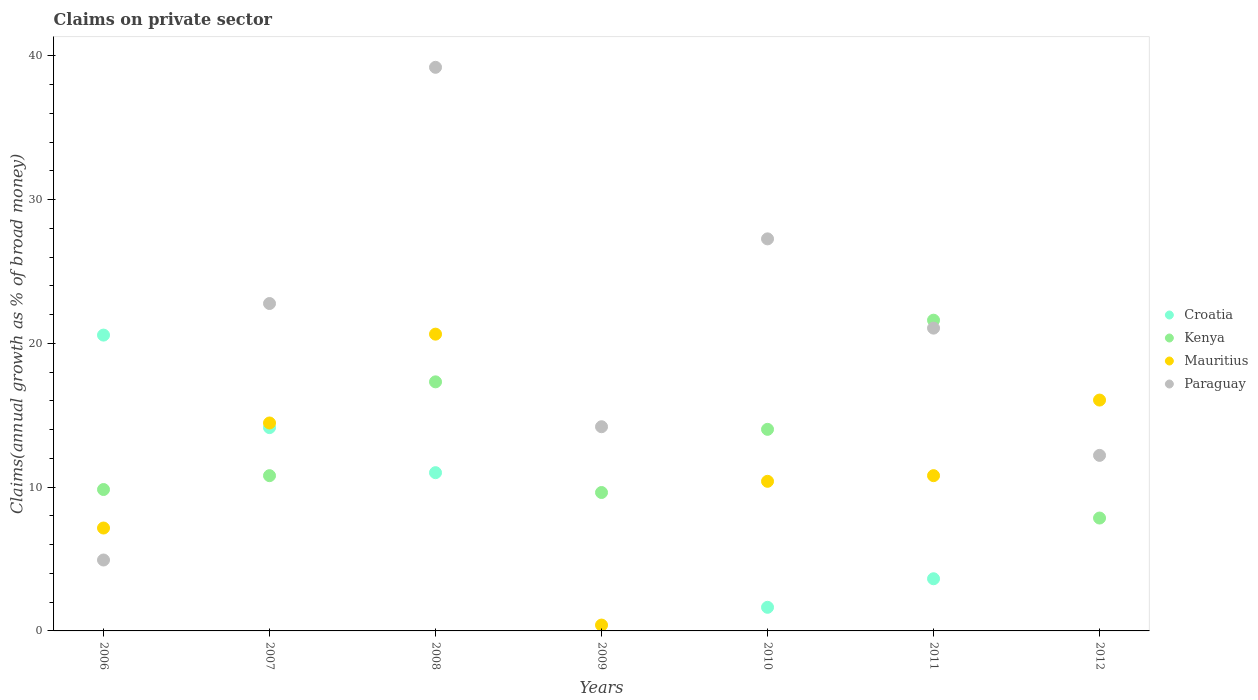How many different coloured dotlines are there?
Your response must be concise. 4. What is the percentage of broad money claimed on private sector in Croatia in 2012?
Give a very brief answer. 0. Across all years, what is the maximum percentage of broad money claimed on private sector in Kenya?
Your response must be concise. 21.62. In which year was the percentage of broad money claimed on private sector in Croatia maximum?
Your response must be concise. 2006. What is the total percentage of broad money claimed on private sector in Croatia in the graph?
Give a very brief answer. 51. What is the difference between the percentage of broad money claimed on private sector in Mauritius in 2010 and that in 2011?
Keep it short and to the point. -0.39. What is the difference between the percentage of broad money claimed on private sector in Croatia in 2011 and the percentage of broad money claimed on private sector in Paraguay in 2008?
Provide a short and direct response. -35.58. What is the average percentage of broad money claimed on private sector in Kenya per year?
Give a very brief answer. 13.01. In the year 2007, what is the difference between the percentage of broad money claimed on private sector in Kenya and percentage of broad money claimed on private sector in Paraguay?
Ensure brevity in your answer.  -11.98. In how many years, is the percentage of broad money claimed on private sector in Mauritius greater than 32 %?
Offer a very short reply. 0. What is the ratio of the percentage of broad money claimed on private sector in Paraguay in 2010 to that in 2011?
Your answer should be very brief. 1.29. Is the difference between the percentage of broad money claimed on private sector in Kenya in 2006 and 2008 greater than the difference between the percentage of broad money claimed on private sector in Paraguay in 2006 and 2008?
Your answer should be very brief. Yes. What is the difference between the highest and the second highest percentage of broad money claimed on private sector in Croatia?
Provide a succinct answer. 6.44. What is the difference between the highest and the lowest percentage of broad money claimed on private sector in Croatia?
Your answer should be compact. 20.58. In how many years, is the percentage of broad money claimed on private sector in Kenya greater than the average percentage of broad money claimed on private sector in Kenya taken over all years?
Keep it short and to the point. 3. Is the sum of the percentage of broad money claimed on private sector in Paraguay in 2006 and 2010 greater than the maximum percentage of broad money claimed on private sector in Kenya across all years?
Provide a succinct answer. Yes. Is the percentage of broad money claimed on private sector in Mauritius strictly greater than the percentage of broad money claimed on private sector in Paraguay over the years?
Give a very brief answer. No. How many dotlines are there?
Provide a short and direct response. 4. What is the difference between two consecutive major ticks on the Y-axis?
Your response must be concise. 10. Are the values on the major ticks of Y-axis written in scientific E-notation?
Your answer should be compact. No. Does the graph contain grids?
Ensure brevity in your answer.  No. How are the legend labels stacked?
Ensure brevity in your answer.  Vertical. What is the title of the graph?
Provide a short and direct response. Claims on private sector. Does "Bolivia" appear as one of the legend labels in the graph?
Ensure brevity in your answer.  No. What is the label or title of the Y-axis?
Offer a very short reply. Claims(annual growth as % of broad money). What is the Claims(annual growth as % of broad money) in Croatia in 2006?
Keep it short and to the point. 20.58. What is the Claims(annual growth as % of broad money) in Kenya in 2006?
Give a very brief answer. 9.84. What is the Claims(annual growth as % of broad money) of Mauritius in 2006?
Offer a very short reply. 7.16. What is the Claims(annual growth as % of broad money) of Paraguay in 2006?
Ensure brevity in your answer.  4.93. What is the Claims(annual growth as % of broad money) in Croatia in 2007?
Offer a terse response. 14.14. What is the Claims(annual growth as % of broad money) of Kenya in 2007?
Provide a succinct answer. 10.8. What is the Claims(annual growth as % of broad money) of Mauritius in 2007?
Give a very brief answer. 14.47. What is the Claims(annual growth as % of broad money) of Paraguay in 2007?
Offer a terse response. 22.78. What is the Claims(annual growth as % of broad money) of Croatia in 2008?
Your answer should be very brief. 11.01. What is the Claims(annual growth as % of broad money) in Kenya in 2008?
Offer a terse response. 17.33. What is the Claims(annual growth as % of broad money) of Mauritius in 2008?
Offer a terse response. 20.65. What is the Claims(annual growth as % of broad money) of Paraguay in 2008?
Give a very brief answer. 39.21. What is the Claims(annual growth as % of broad money) of Croatia in 2009?
Make the answer very short. 0. What is the Claims(annual growth as % of broad money) of Kenya in 2009?
Provide a succinct answer. 9.63. What is the Claims(annual growth as % of broad money) in Mauritius in 2009?
Provide a short and direct response. 0.41. What is the Claims(annual growth as % of broad money) in Paraguay in 2009?
Keep it short and to the point. 14.2. What is the Claims(annual growth as % of broad money) in Croatia in 2010?
Make the answer very short. 1.64. What is the Claims(annual growth as % of broad money) of Kenya in 2010?
Your response must be concise. 14.02. What is the Claims(annual growth as % of broad money) of Mauritius in 2010?
Offer a terse response. 10.41. What is the Claims(annual growth as % of broad money) in Paraguay in 2010?
Provide a short and direct response. 27.27. What is the Claims(annual growth as % of broad money) in Croatia in 2011?
Offer a very short reply. 3.63. What is the Claims(annual growth as % of broad money) of Kenya in 2011?
Make the answer very short. 21.62. What is the Claims(annual growth as % of broad money) of Mauritius in 2011?
Your answer should be very brief. 10.8. What is the Claims(annual growth as % of broad money) of Paraguay in 2011?
Offer a terse response. 21.06. What is the Claims(annual growth as % of broad money) of Kenya in 2012?
Provide a short and direct response. 7.85. What is the Claims(annual growth as % of broad money) in Mauritius in 2012?
Offer a very short reply. 16.06. What is the Claims(annual growth as % of broad money) of Paraguay in 2012?
Offer a terse response. 12.21. Across all years, what is the maximum Claims(annual growth as % of broad money) of Croatia?
Your response must be concise. 20.58. Across all years, what is the maximum Claims(annual growth as % of broad money) of Kenya?
Your response must be concise. 21.62. Across all years, what is the maximum Claims(annual growth as % of broad money) of Mauritius?
Offer a terse response. 20.65. Across all years, what is the maximum Claims(annual growth as % of broad money) in Paraguay?
Your answer should be very brief. 39.21. Across all years, what is the minimum Claims(annual growth as % of broad money) in Croatia?
Provide a short and direct response. 0. Across all years, what is the minimum Claims(annual growth as % of broad money) in Kenya?
Provide a short and direct response. 7.85. Across all years, what is the minimum Claims(annual growth as % of broad money) of Mauritius?
Your response must be concise. 0.41. Across all years, what is the minimum Claims(annual growth as % of broad money) of Paraguay?
Make the answer very short. 4.93. What is the total Claims(annual growth as % of broad money) in Croatia in the graph?
Provide a short and direct response. 51. What is the total Claims(annual growth as % of broad money) of Kenya in the graph?
Give a very brief answer. 91.09. What is the total Claims(annual growth as % of broad money) of Mauritius in the graph?
Offer a terse response. 79.95. What is the total Claims(annual growth as % of broad money) in Paraguay in the graph?
Keep it short and to the point. 141.67. What is the difference between the Claims(annual growth as % of broad money) in Croatia in 2006 and that in 2007?
Keep it short and to the point. 6.44. What is the difference between the Claims(annual growth as % of broad money) of Kenya in 2006 and that in 2007?
Provide a succinct answer. -0.96. What is the difference between the Claims(annual growth as % of broad money) in Mauritius in 2006 and that in 2007?
Offer a terse response. -7.31. What is the difference between the Claims(annual growth as % of broad money) of Paraguay in 2006 and that in 2007?
Offer a very short reply. -17.84. What is the difference between the Claims(annual growth as % of broad money) of Croatia in 2006 and that in 2008?
Provide a short and direct response. 9.57. What is the difference between the Claims(annual growth as % of broad money) of Kenya in 2006 and that in 2008?
Your response must be concise. -7.49. What is the difference between the Claims(annual growth as % of broad money) in Mauritius in 2006 and that in 2008?
Provide a short and direct response. -13.49. What is the difference between the Claims(annual growth as % of broad money) of Paraguay in 2006 and that in 2008?
Provide a succinct answer. -34.28. What is the difference between the Claims(annual growth as % of broad money) in Kenya in 2006 and that in 2009?
Your response must be concise. 0.21. What is the difference between the Claims(annual growth as % of broad money) of Mauritius in 2006 and that in 2009?
Give a very brief answer. 6.75. What is the difference between the Claims(annual growth as % of broad money) in Paraguay in 2006 and that in 2009?
Provide a succinct answer. -9.27. What is the difference between the Claims(annual growth as % of broad money) in Croatia in 2006 and that in 2010?
Your response must be concise. 18.94. What is the difference between the Claims(annual growth as % of broad money) in Kenya in 2006 and that in 2010?
Your response must be concise. -4.19. What is the difference between the Claims(annual growth as % of broad money) in Mauritius in 2006 and that in 2010?
Make the answer very short. -3.25. What is the difference between the Claims(annual growth as % of broad money) of Paraguay in 2006 and that in 2010?
Your answer should be very brief. -22.34. What is the difference between the Claims(annual growth as % of broad money) in Croatia in 2006 and that in 2011?
Provide a succinct answer. 16.95. What is the difference between the Claims(annual growth as % of broad money) of Kenya in 2006 and that in 2011?
Your answer should be compact. -11.78. What is the difference between the Claims(annual growth as % of broad money) in Mauritius in 2006 and that in 2011?
Offer a very short reply. -3.64. What is the difference between the Claims(annual growth as % of broad money) of Paraguay in 2006 and that in 2011?
Make the answer very short. -16.13. What is the difference between the Claims(annual growth as % of broad money) in Kenya in 2006 and that in 2012?
Make the answer very short. 1.98. What is the difference between the Claims(annual growth as % of broad money) in Mauritius in 2006 and that in 2012?
Your answer should be very brief. -8.9. What is the difference between the Claims(annual growth as % of broad money) in Paraguay in 2006 and that in 2012?
Provide a succinct answer. -7.28. What is the difference between the Claims(annual growth as % of broad money) of Croatia in 2007 and that in 2008?
Offer a terse response. 3.14. What is the difference between the Claims(annual growth as % of broad money) in Kenya in 2007 and that in 2008?
Offer a very short reply. -6.53. What is the difference between the Claims(annual growth as % of broad money) in Mauritius in 2007 and that in 2008?
Offer a terse response. -6.18. What is the difference between the Claims(annual growth as % of broad money) in Paraguay in 2007 and that in 2008?
Offer a very short reply. -16.43. What is the difference between the Claims(annual growth as % of broad money) in Kenya in 2007 and that in 2009?
Ensure brevity in your answer.  1.17. What is the difference between the Claims(annual growth as % of broad money) of Mauritius in 2007 and that in 2009?
Provide a succinct answer. 14.06. What is the difference between the Claims(annual growth as % of broad money) of Paraguay in 2007 and that in 2009?
Provide a short and direct response. 8.57. What is the difference between the Claims(annual growth as % of broad money) in Croatia in 2007 and that in 2010?
Offer a terse response. 12.5. What is the difference between the Claims(annual growth as % of broad money) of Kenya in 2007 and that in 2010?
Give a very brief answer. -3.22. What is the difference between the Claims(annual growth as % of broad money) of Mauritius in 2007 and that in 2010?
Offer a very short reply. 4.06. What is the difference between the Claims(annual growth as % of broad money) of Paraguay in 2007 and that in 2010?
Provide a succinct answer. -4.5. What is the difference between the Claims(annual growth as % of broad money) in Croatia in 2007 and that in 2011?
Offer a terse response. 10.52. What is the difference between the Claims(annual growth as % of broad money) in Kenya in 2007 and that in 2011?
Provide a short and direct response. -10.82. What is the difference between the Claims(annual growth as % of broad money) of Mauritius in 2007 and that in 2011?
Provide a short and direct response. 3.67. What is the difference between the Claims(annual growth as % of broad money) in Paraguay in 2007 and that in 2011?
Ensure brevity in your answer.  1.71. What is the difference between the Claims(annual growth as % of broad money) in Kenya in 2007 and that in 2012?
Your answer should be compact. 2.95. What is the difference between the Claims(annual growth as % of broad money) in Mauritius in 2007 and that in 2012?
Your response must be concise. -1.59. What is the difference between the Claims(annual growth as % of broad money) of Paraguay in 2007 and that in 2012?
Offer a very short reply. 10.56. What is the difference between the Claims(annual growth as % of broad money) of Kenya in 2008 and that in 2009?
Provide a succinct answer. 7.7. What is the difference between the Claims(annual growth as % of broad money) in Mauritius in 2008 and that in 2009?
Provide a succinct answer. 20.24. What is the difference between the Claims(annual growth as % of broad money) of Paraguay in 2008 and that in 2009?
Your answer should be very brief. 25. What is the difference between the Claims(annual growth as % of broad money) in Croatia in 2008 and that in 2010?
Keep it short and to the point. 9.37. What is the difference between the Claims(annual growth as % of broad money) in Kenya in 2008 and that in 2010?
Your answer should be compact. 3.3. What is the difference between the Claims(annual growth as % of broad money) in Mauritius in 2008 and that in 2010?
Provide a short and direct response. 10.24. What is the difference between the Claims(annual growth as % of broad money) in Paraguay in 2008 and that in 2010?
Make the answer very short. 11.93. What is the difference between the Claims(annual growth as % of broad money) in Croatia in 2008 and that in 2011?
Your response must be concise. 7.38. What is the difference between the Claims(annual growth as % of broad money) of Kenya in 2008 and that in 2011?
Ensure brevity in your answer.  -4.29. What is the difference between the Claims(annual growth as % of broad money) in Mauritius in 2008 and that in 2011?
Make the answer very short. 9.84. What is the difference between the Claims(annual growth as % of broad money) in Paraguay in 2008 and that in 2011?
Offer a terse response. 18.14. What is the difference between the Claims(annual growth as % of broad money) of Kenya in 2008 and that in 2012?
Ensure brevity in your answer.  9.47. What is the difference between the Claims(annual growth as % of broad money) in Mauritius in 2008 and that in 2012?
Provide a short and direct response. 4.59. What is the difference between the Claims(annual growth as % of broad money) in Paraguay in 2008 and that in 2012?
Provide a short and direct response. 27. What is the difference between the Claims(annual growth as % of broad money) of Kenya in 2009 and that in 2010?
Offer a terse response. -4.39. What is the difference between the Claims(annual growth as % of broad money) in Mauritius in 2009 and that in 2010?
Offer a very short reply. -10. What is the difference between the Claims(annual growth as % of broad money) in Paraguay in 2009 and that in 2010?
Provide a short and direct response. -13.07. What is the difference between the Claims(annual growth as % of broad money) in Kenya in 2009 and that in 2011?
Offer a very short reply. -11.99. What is the difference between the Claims(annual growth as % of broad money) of Mauritius in 2009 and that in 2011?
Make the answer very short. -10.39. What is the difference between the Claims(annual growth as % of broad money) in Paraguay in 2009 and that in 2011?
Offer a terse response. -6.86. What is the difference between the Claims(annual growth as % of broad money) in Kenya in 2009 and that in 2012?
Your answer should be compact. 1.78. What is the difference between the Claims(annual growth as % of broad money) of Mauritius in 2009 and that in 2012?
Offer a very short reply. -15.65. What is the difference between the Claims(annual growth as % of broad money) of Paraguay in 2009 and that in 2012?
Your response must be concise. 1.99. What is the difference between the Claims(annual growth as % of broad money) of Croatia in 2010 and that in 2011?
Give a very brief answer. -1.99. What is the difference between the Claims(annual growth as % of broad money) of Kenya in 2010 and that in 2011?
Your response must be concise. -7.59. What is the difference between the Claims(annual growth as % of broad money) of Mauritius in 2010 and that in 2011?
Offer a very short reply. -0.39. What is the difference between the Claims(annual growth as % of broad money) of Paraguay in 2010 and that in 2011?
Provide a succinct answer. 6.21. What is the difference between the Claims(annual growth as % of broad money) in Kenya in 2010 and that in 2012?
Your answer should be very brief. 6.17. What is the difference between the Claims(annual growth as % of broad money) of Mauritius in 2010 and that in 2012?
Offer a terse response. -5.65. What is the difference between the Claims(annual growth as % of broad money) of Paraguay in 2010 and that in 2012?
Provide a short and direct response. 15.06. What is the difference between the Claims(annual growth as % of broad money) of Kenya in 2011 and that in 2012?
Your answer should be compact. 13.76. What is the difference between the Claims(annual growth as % of broad money) in Mauritius in 2011 and that in 2012?
Your response must be concise. -5.26. What is the difference between the Claims(annual growth as % of broad money) of Paraguay in 2011 and that in 2012?
Your answer should be compact. 8.85. What is the difference between the Claims(annual growth as % of broad money) of Croatia in 2006 and the Claims(annual growth as % of broad money) of Kenya in 2007?
Provide a succinct answer. 9.78. What is the difference between the Claims(annual growth as % of broad money) in Croatia in 2006 and the Claims(annual growth as % of broad money) in Mauritius in 2007?
Your answer should be compact. 6.11. What is the difference between the Claims(annual growth as % of broad money) of Croatia in 2006 and the Claims(annual growth as % of broad money) of Paraguay in 2007?
Make the answer very short. -2.2. What is the difference between the Claims(annual growth as % of broad money) of Kenya in 2006 and the Claims(annual growth as % of broad money) of Mauritius in 2007?
Make the answer very short. -4.63. What is the difference between the Claims(annual growth as % of broad money) of Kenya in 2006 and the Claims(annual growth as % of broad money) of Paraguay in 2007?
Provide a short and direct response. -12.94. What is the difference between the Claims(annual growth as % of broad money) of Mauritius in 2006 and the Claims(annual growth as % of broad money) of Paraguay in 2007?
Give a very brief answer. -15.62. What is the difference between the Claims(annual growth as % of broad money) of Croatia in 2006 and the Claims(annual growth as % of broad money) of Kenya in 2008?
Ensure brevity in your answer.  3.25. What is the difference between the Claims(annual growth as % of broad money) in Croatia in 2006 and the Claims(annual growth as % of broad money) in Mauritius in 2008?
Give a very brief answer. -0.07. What is the difference between the Claims(annual growth as % of broad money) in Croatia in 2006 and the Claims(annual growth as % of broad money) in Paraguay in 2008?
Your answer should be very brief. -18.63. What is the difference between the Claims(annual growth as % of broad money) of Kenya in 2006 and the Claims(annual growth as % of broad money) of Mauritius in 2008?
Your answer should be very brief. -10.81. What is the difference between the Claims(annual growth as % of broad money) of Kenya in 2006 and the Claims(annual growth as % of broad money) of Paraguay in 2008?
Offer a very short reply. -29.37. What is the difference between the Claims(annual growth as % of broad money) of Mauritius in 2006 and the Claims(annual growth as % of broad money) of Paraguay in 2008?
Your answer should be very brief. -32.05. What is the difference between the Claims(annual growth as % of broad money) of Croatia in 2006 and the Claims(annual growth as % of broad money) of Kenya in 2009?
Ensure brevity in your answer.  10.95. What is the difference between the Claims(annual growth as % of broad money) of Croatia in 2006 and the Claims(annual growth as % of broad money) of Mauritius in 2009?
Provide a short and direct response. 20.17. What is the difference between the Claims(annual growth as % of broad money) in Croatia in 2006 and the Claims(annual growth as % of broad money) in Paraguay in 2009?
Ensure brevity in your answer.  6.37. What is the difference between the Claims(annual growth as % of broad money) of Kenya in 2006 and the Claims(annual growth as % of broad money) of Mauritius in 2009?
Make the answer very short. 9.43. What is the difference between the Claims(annual growth as % of broad money) in Kenya in 2006 and the Claims(annual growth as % of broad money) in Paraguay in 2009?
Make the answer very short. -4.37. What is the difference between the Claims(annual growth as % of broad money) in Mauritius in 2006 and the Claims(annual growth as % of broad money) in Paraguay in 2009?
Your answer should be compact. -7.05. What is the difference between the Claims(annual growth as % of broad money) in Croatia in 2006 and the Claims(annual growth as % of broad money) in Kenya in 2010?
Offer a very short reply. 6.56. What is the difference between the Claims(annual growth as % of broad money) of Croatia in 2006 and the Claims(annual growth as % of broad money) of Mauritius in 2010?
Your answer should be compact. 10.17. What is the difference between the Claims(annual growth as % of broad money) in Croatia in 2006 and the Claims(annual growth as % of broad money) in Paraguay in 2010?
Keep it short and to the point. -6.69. What is the difference between the Claims(annual growth as % of broad money) of Kenya in 2006 and the Claims(annual growth as % of broad money) of Mauritius in 2010?
Provide a short and direct response. -0.57. What is the difference between the Claims(annual growth as % of broad money) in Kenya in 2006 and the Claims(annual growth as % of broad money) in Paraguay in 2010?
Your answer should be very brief. -17.44. What is the difference between the Claims(annual growth as % of broad money) in Mauritius in 2006 and the Claims(annual growth as % of broad money) in Paraguay in 2010?
Your answer should be very brief. -20.12. What is the difference between the Claims(annual growth as % of broad money) in Croatia in 2006 and the Claims(annual growth as % of broad money) in Kenya in 2011?
Your response must be concise. -1.04. What is the difference between the Claims(annual growth as % of broad money) of Croatia in 2006 and the Claims(annual growth as % of broad money) of Mauritius in 2011?
Make the answer very short. 9.78. What is the difference between the Claims(annual growth as % of broad money) in Croatia in 2006 and the Claims(annual growth as % of broad money) in Paraguay in 2011?
Your answer should be very brief. -0.48. What is the difference between the Claims(annual growth as % of broad money) in Kenya in 2006 and the Claims(annual growth as % of broad money) in Mauritius in 2011?
Your answer should be compact. -0.96. What is the difference between the Claims(annual growth as % of broad money) of Kenya in 2006 and the Claims(annual growth as % of broad money) of Paraguay in 2011?
Offer a very short reply. -11.23. What is the difference between the Claims(annual growth as % of broad money) of Mauritius in 2006 and the Claims(annual growth as % of broad money) of Paraguay in 2011?
Make the answer very short. -13.91. What is the difference between the Claims(annual growth as % of broad money) of Croatia in 2006 and the Claims(annual growth as % of broad money) of Kenya in 2012?
Provide a short and direct response. 12.73. What is the difference between the Claims(annual growth as % of broad money) in Croatia in 2006 and the Claims(annual growth as % of broad money) in Mauritius in 2012?
Offer a very short reply. 4.52. What is the difference between the Claims(annual growth as % of broad money) in Croatia in 2006 and the Claims(annual growth as % of broad money) in Paraguay in 2012?
Ensure brevity in your answer.  8.37. What is the difference between the Claims(annual growth as % of broad money) in Kenya in 2006 and the Claims(annual growth as % of broad money) in Mauritius in 2012?
Offer a very short reply. -6.22. What is the difference between the Claims(annual growth as % of broad money) of Kenya in 2006 and the Claims(annual growth as % of broad money) of Paraguay in 2012?
Your answer should be very brief. -2.38. What is the difference between the Claims(annual growth as % of broad money) in Mauritius in 2006 and the Claims(annual growth as % of broad money) in Paraguay in 2012?
Offer a very short reply. -5.05. What is the difference between the Claims(annual growth as % of broad money) of Croatia in 2007 and the Claims(annual growth as % of broad money) of Kenya in 2008?
Provide a short and direct response. -3.18. What is the difference between the Claims(annual growth as % of broad money) in Croatia in 2007 and the Claims(annual growth as % of broad money) in Mauritius in 2008?
Give a very brief answer. -6.5. What is the difference between the Claims(annual growth as % of broad money) in Croatia in 2007 and the Claims(annual growth as % of broad money) in Paraguay in 2008?
Your answer should be very brief. -25.06. What is the difference between the Claims(annual growth as % of broad money) of Kenya in 2007 and the Claims(annual growth as % of broad money) of Mauritius in 2008?
Ensure brevity in your answer.  -9.85. What is the difference between the Claims(annual growth as % of broad money) in Kenya in 2007 and the Claims(annual growth as % of broad money) in Paraguay in 2008?
Give a very brief answer. -28.41. What is the difference between the Claims(annual growth as % of broad money) of Mauritius in 2007 and the Claims(annual growth as % of broad money) of Paraguay in 2008?
Offer a terse response. -24.74. What is the difference between the Claims(annual growth as % of broad money) of Croatia in 2007 and the Claims(annual growth as % of broad money) of Kenya in 2009?
Offer a terse response. 4.52. What is the difference between the Claims(annual growth as % of broad money) of Croatia in 2007 and the Claims(annual growth as % of broad money) of Mauritius in 2009?
Provide a succinct answer. 13.74. What is the difference between the Claims(annual growth as % of broad money) of Croatia in 2007 and the Claims(annual growth as % of broad money) of Paraguay in 2009?
Ensure brevity in your answer.  -0.06. What is the difference between the Claims(annual growth as % of broad money) of Kenya in 2007 and the Claims(annual growth as % of broad money) of Mauritius in 2009?
Keep it short and to the point. 10.39. What is the difference between the Claims(annual growth as % of broad money) of Kenya in 2007 and the Claims(annual growth as % of broad money) of Paraguay in 2009?
Provide a succinct answer. -3.4. What is the difference between the Claims(annual growth as % of broad money) of Mauritius in 2007 and the Claims(annual growth as % of broad money) of Paraguay in 2009?
Your answer should be very brief. 0.26. What is the difference between the Claims(annual growth as % of broad money) in Croatia in 2007 and the Claims(annual growth as % of broad money) in Kenya in 2010?
Your answer should be compact. 0.12. What is the difference between the Claims(annual growth as % of broad money) of Croatia in 2007 and the Claims(annual growth as % of broad money) of Mauritius in 2010?
Ensure brevity in your answer.  3.74. What is the difference between the Claims(annual growth as % of broad money) of Croatia in 2007 and the Claims(annual growth as % of broad money) of Paraguay in 2010?
Ensure brevity in your answer.  -13.13. What is the difference between the Claims(annual growth as % of broad money) in Kenya in 2007 and the Claims(annual growth as % of broad money) in Mauritius in 2010?
Offer a terse response. 0.39. What is the difference between the Claims(annual growth as % of broad money) of Kenya in 2007 and the Claims(annual growth as % of broad money) of Paraguay in 2010?
Make the answer very short. -16.47. What is the difference between the Claims(annual growth as % of broad money) of Mauritius in 2007 and the Claims(annual growth as % of broad money) of Paraguay in 2010?
Make the answer very short. -12.81. What is the difference between the Claims(annual growth as % of broad money) of Croatia in 2007 and the Claims(annual growth as % of broad money) of Kenya in 2011?
Your response must be concise. -7.47. What is the difference between the Claims(annual growth as % of broad money) of Croatia in 2007 and the Claims(annual growth as % of broad money) of Mauritius in 2011?
Provide a succinct answer. 3.34. What is the difference between the Claims(annual growth as % of broad money) in Croatia in 2007 and the Claims(annual growth as % of broad money) in Paraguay in 2011?
Offer a very short reply. -6.92. What is the difference between the Claims(annual growth as % of broad money) in Kenya in 2007 and the Claims(annual growth as % of broad money) in Mauritius in 2011?
Provide a succinct answer. -0. What is the difference between the Claims(annual growth as % of broad money) in Kenya in 2007 and the Claims(annual growth as % of broad money) in Paraguay in 2011?
Offer a terse response. -10.26. What is the difference between the Claims(annual growth as % of broad money) of Mauritius in 2007 and the Claims(annual growth as % of broad money) of Paraguay in 2011?
Make the answer very short. -6.6. What is the difference between the Claims(annual growth as % of broad money) of Croatia in 2007 and the Claims(annual growth as % of broad money) of Kenya in 2012?
Keep it short and to the point. 6.29. What is the difference between the Claims(annual growth as % of broad money) of Croatia in 2007 and the Claims(annual growth as % of broad money) of Mauritius in 2012?
Make the answer very short. -1.92. What is the difference between the Claims(annual growth as % of broad money) in Croatia in 2007 and the Claims(annual growth as % of broad money) in Paraguay in 2012?
Give a very brief answer. 1.93. What is the difference between the Claims(annual growth as % of broad money) in Kenya in 2007 and the Claims(annual growth as % of broad money) in Mauritius in 2012?
Ensure brevity in your answer.  -5.26. What is the difference between the Claims(annual growth as % of broad money) of Kenya in 2007 and the Claims(annual growth as % of broad money) of Paraguay in 2012?
Give a very brief answer. -1.41. What is the difference between the Claims(annual growth as % of broad money) in Mauritius in 2007 and the Claims(annual growth as % of broad money) in Paraguay in 2012?
Provide a succinct answer. 2.25. What is the difference between the Claims(annual growth as % of broad money) in Croatia in 2008 and the Claims(annual growth as % of broad money) in Kenya in 2009?
Your answer should be very brief. 1.38. What is the difference between the Claims(annual growth as % of broad money) of Croatia in 2008 and the Claims(annual growth as % of broad money) of Mauritius in 2009?
Your answer should be very brief. 10.6. What is the difference between the Claims(annual growth as % of broad money) in Croatia in 2008 and the Claims(annual growth as % of broad money) in Paraguay in 2009?
Provide a succinct answer. -3.2. What is the difference between the Claims(annual growth as % of broad money) in Kenya in 2008 and the Claims(annual growth as % of broad money) in Mauritius in 2009?
Provide a short and direct response. 16.92. What is the difference between the Claims(annual growth as % of broad money) in Kenya in 2008 and the Claims(annual growth as % of broad money) in Paraguay in 2009?
Your answer should be compact. 3.12. What is the difference between the Claims(annual growth as % of broad money) of Mauritius in 2008 and the Claims(annual growth as % of broad money) of Paraguay in 2009?
Offer a very short reply. 6.44. What is the difference between the Claims(annual growth as % of broad money) in Croatia in 2008 and the Claims(annual growth as % of broad money) in Kenya in 2010?
Make the answer very short. -3.01. What is the difference between the Claims(annual growth as % of broad money) of Croatia in 2008 and the Claims(annual growth as % of broad money) of Mauritius in 2010?
Make the answer very short. 0.6. What is the difference between the Claims(annual growth as % of broad money) in Croatia in 2008 and the Claims(annual growth as % of broad money) in Paraguay in 2010?
Give a very brief answer. -16.27. What is the difference between the Claims(annual growth as % of broad money) of Kenya in 2008 and the Claims(annual growth as % of broad money) of Mauritius in 2010?
Ensure brevity in your answer.  6.92. What is the difference between the Claims(annual growth as % of broad money) in Kenya in 2008 and the Claims(annual growth as % of broad money) in Paraguay in 2010?
Give a very brief answer. -9.95. What is the difference between the Claims(annual growth as % of broad money) in Mauritius in 2008 and the Claims(annual growth as % of broad money) in Paraguay in 2010?
Your response must be concise. -6.63. What is the difference between the Claims(annual growth as % of broad money) of Croatia in 2008 and the Claims(annual growth as % of broad money) of Kenya in 2011?
Provide a succinct answer. -10.61. What is the difference between the Claims(annual growth as % of broad money) in Croatia in 2008 and the Claims(annual growth as % of broad money) in Mauritius in 2011?
Give a very brief answer. 0.21. What is the difference between the Claims(annual growth as % of broad money) in Croatia in 2008 and the Claims(annual growth as % of broad money) in Paraguay in 2011?
Offer a very short reply. -10.06. What is the difference between the Claims(annual growth as % of broad money) of Kenya in 2008 and the Claims(annual growth as % of broad money) of Mauritius in 2011?
Your answer should be compact. 6.53. What is the difference between the Claims(annual growth as % of broad money) of Kenya in 2008 and the Claims(annual growth as % of broad money) of Paraguay in 2011?
Ensure brevity in your answer.  -3.74. What is the difference between the Claims(annual growth as % of broad money) of Mauritius in 2008 and the Claims(annual growth as % of broad money) of Paraguay in 2011?
Your answer should be very brief. -0.42. What is the difference between the Claims(annual growth as % of broad money) in Croatia in 2008 and the Claims(annual growth as % of broad money) in Kenya in 2012?
Offer a terse response. 3.16. What is the difference between the Claims(annual growth as % of broad money) of Croatia in 2008 and the Claims(annual growth as % of broad money) of Mauritius in 2012?
Keep it short and to the point. -5.05. What is the difference between the Claims(annual growth as % of broad money) in Croatia in 2008 and the Claims(annual growth as % of broad money) in Paraguay in 2012?
Provide a succinct answer. -1.2. What is the difference between the Claims(annual growth as % of broad money) in Kenya in 2008 and the Claims(annual growth as % of broad money) in Mauritius in 2012?
Offer a very short reply. 1.27. What is the difference between the Claims(annual growth as % of broad money) of Kenya in 2008 and the Claims(annual growth as % of broad money) of Paraguay in 2012?
Give a very brief answer. 5.11. What is the difference between the Claims(annual growth as % of broad money) of Mauritius in 2008 and the Claims(annual growth as % of broad money) of Paraguay in 2012?
Your response must be concise. 8.43. What is the difference between the Claims(annual growth as % of broad money) in Kenya in 2009 and the Claims(annual growth as % of broad money) in Mauritius in 2010?
Provide a short and direct response. -0.78. What is the difference between the Claims(annual growth as % of broad money) in Kenya in 2009 and the Claims(annual growth as % of broad money) in Paraguay in 2010?
Ensure brevity in your answer.  -17.64. What is the difference between the Claims(annual growth as % of broad money) in Mauritius in 2009 and the Claims(annual growth as % of broad money) in Paraguay in 2010?
Ensure brevity in your answer.  -26.87. What is the difference between the Claims(annual growth as % of broad money) of Kenya in 2009 and the Claims(annual growth as % of broad money) of Mauritius in 2011?
Your answer should be very brief. -1.17. What is the difference between the Claims(annual growth as % of broad money) in Kenya in 2009 and the Claims(annual growth as % of broad money) in Paraguay in 2011?
Your response must be concise. -11.44. What is the difference between the Claims(annual growth as % of broad money) of Mauritius in 2009 and the Claims(annual growth as % of broad money) of Paraguay in 2011?
Provide a short and direct response. -20.66. What is the difference between the Claims(annual growth as % of broad money) of Kenya in 2009 and the Claims(annual growth as % of broad money) of Mauritius in 2012?
Ensure brevity in your answer.  -6.43. What is the difference between the Claims(annual growth as % of broad money) of Kenya in 2009 and the Claims(annual growth as % of broad money) of Paraguay in 2012?
Offer a very short reply. -2.58. What is the difference between the Claims(annual growth as % of broad money) of Mauritius in 2009 and the Claims(annual growth as % of broad money) of Paraguay in 2012?
Provide a short and direct response. -11.81. What is the difference between the Claims(annual growth as % of broad money) of Croatia in 2010 and the Claims(annual growth as % of broad money) of Kenya in 2011?
Provide a short and direct response. -19.97. What is the difference between the Claims(annual growth as % of broad money) of Croatia in 2010 and the Claims(annual growth as % of broad money) of Mauritius in 2011?
Your response must be concise. -9.16. What is the difference between the Claims(annual growth as % of broad money) of Croatia in 2010 and the Claims(annual growth as % of broad money) of Paraguay in 2011?
Your answer should be compact. -19.42. What is the difference between the Claims(annual growth as % of broad money) in Kenya in 2010 and the Claims(annual growth as % of broad money) in Mauritius in 2011?
Give a very brief answer. 3.22. What is the difference between the Claims(annual growth as % of broad money) in Kenya in 2010 and the Claims(annual growth as % of broad money) in Paraguay in 2011?
Provide a succinct answer. -7.04. What is the difference between the Claims(annual growth as % of broad money) in Mauritius in 2010 and the Claims(annual growth as % of broad money) in Paraguay in 2011?
Ensure brevity in your answer.  -10.66. What is the difference between the Claims(annual growth as % of broad money) in Croatia in 2010 and the Claims(annual growth as % of broad money) in Kenya in 2012?
Make the answer very short. -6.21. What is the difference between the Claims(annual growth as % of broad money) of Croatia in 2010 and the Claims(annual growth as % of broad money) of Mauritius in 2012?
Your answer should be compact. -14.42. What is the difference between the Claims(annual growth as % of broad money) in Croatia in 2010 and the Claims(annual growth as % of broad money) in Paraguay in 2012?
Offer a very short reply. -10.57. What is the difference between the Claims(annual growth as % of broad money) of Kenya in 2010 and the Claims(annual growth as % of broad money) of Mauritius in 2012?
Offer a terse response. -2.04. What is the difference between the Claims(annual growth as % of broad money) of Kenya in 2010 and the Claims(annual growth as % of broad money) of Paraguay in 2012?
Offer a terse response. 1.81. What is the difference between the Claims(annual growth as % of broad money) of Mauritius in 2010 and the Claims(annual growth as % of broad money) of Paraguay in 2012?
Your response must be concise. -1.8. What is the difference between the Claims(annual growth as % of broad money) of Croatia in 2011 and the Claims(annual growth as % of broad money) of Kenya in 2012?
Provide a short and direct response. -4.22. What is the difference between the Claims(annual growth as % of broad money) of Croatia in 2011 and the Claims(annual growth as % of broad money) of Mauritius in 2012?
Provide a short and direct response. -12.43. What is the difference between the Claims(annual growth as % of broad money) of Croatia in 2011 and the Claims(annual growth as % of broad money) of Paraguay in 2012?
Offer a terse response. -8.58. What is the difference between the Claims(annual growth as % of broad money) of Kenya in 2011 and the Claims(annual growth as % of broad money) of Mauritius in 2012?
Make the answer very short. 5.56. What is the difference between the Claims(annual growth as % of broad money) of Kenya in 2011 and the Claims(annual growth as % of broad money) of Paraguay in 2012?
Give a very brief answer. 9.4. What is the difference between the Claims(annual growth as % of broad money) in Mauritius in 2011 and the Claims(annual growth as % of broad money) in Paraguay in 2012?
Your answer should be compact. -1.41. What is the average Claims(annual growth as % of broad money) of Croatia per year?
Offer a very short reply. 7.29. What is the average Claims(annual growth as % of broad money) of Kenya per year?
Make the answer very short. 13.01. What is the average Claims(annual growth as % of broad money) in Mauritius per year?
Your response must be concise. 11.42. What is the average Claims(annual growth as % of broad money) of Paraguay per year?
Offer a very short reply. 20.24. In the year 2006, what is the difference between the Claims(annual growth as % of broad money) of Croatia and Claims(annual growth as % of broad money) of Kenya?
Ensure brevity in your answer.  10.74. In the year 2006, what is the difference between the Claims(annual growth as % of broad money) of Croatia and Claims(annual growth as % of broad money) of Mauritius?
Your answer should be compact. 13.42. In the year 2006, what is the difference between the Claims(annual growth as % of broad money) in Croatia and Claims(annual growth as % of broad money) in Paraguay?
Offer a very short reply. 15.65. In the year 2006, what is the difference between the Claims(annual growth as % of broad money) in Kenya and Claims(annual growth as % of broad money) in Mauritius?
Offer a very short reply. 2.68. In the year 2006, what is the difference between the Claims(annual growth as % of broad money) of Kenya and Claims(annual growth as % of broad money) of Paraguay?
Your response must be concise. 4.9. In the year 2006, what is the difference between the Claims(annual growth as % of broad money) in Mauritius and Claims(annual growth as % of broad money) in Paraguay?
Offer a terse response. 2.23. In the year 2007, what is the difference between the Claims(annual growth as % of broad money) in Croatia and Claims(annual growth as % of broad money) in Kenya?
Your response must be concise. 3.34. In the year 2007, what is the difference between the Claims(annual growth as % of broad money) of Croatia and Claims(annual growth as % of broad money) of Mauritius?
Make the answer very short. -0.32. In the year 2007, what is the difference between the Claims(annual growth as % of broad money) in Croatia and Claims(annual growth as % of broad money) in Paraguay?
Keep it short and to the point. -8.63. In the year 2007, what is the difference between the Claims(annual growth as % of broad money) in Kenya and Claims(annual growth as % of broad money) in Mauritius?
Ensure brevity in your answer.  -3.67. In the year 2007, what is the difference between the Claims(annual growth as % of broad money) in Kenya and Claims(annual growth as % of broad money) in Paraguay?
Provide a succinct answer. -11.98. In the year 2007, what is the difference between the Claims(annual growth as % of broad money) of Mauritius and Claims(annual growth as % of broad money) of Paraguay?
Your response must be concise. -8.31. In the year 2008, what is the difference between the Claims(annual growth as % of broad money) of Croatia and Claims(annual growth as % of broad money) of Kenya?
Ensure brevity in your answer.  -6.32. In the year 2008, what is the difference between the Claims(annual growth as % of broad money) of Croatia and Claims(annual growth as % of broad money) of Mauritius?
Keep it short and to the point. -9.64. In the year 2008, what is the difference between the Claims(annual growth as % of broad money) of Croatia and Claims(annual growth as % of broad money) of Paraguay?
Make the answer very short. -28.2. In the year 2008, what is the difference between the Claims(annual growth as % of broad money) of Kenya and Claims(annual growth as % of broad money) of Mauritius?
Your answer should be very brief. -3.32. In the year 2008, what is the difference between the Claims(annual growth as % of broad money) in Kenya and Claims(annual growth as % of broad money) in Paraguay?
Offer a very short reply. -21.88. In the year 2008, what is the difference between the Claims(annual growth as % of broad money) of Mauritius and Claims(annual growth as % of broad money) of Paraguay?
Your answer should be very brief. -18.56. In the year 2009, what is the difference between the Claims(annual growth as % of broad money) in Kenya and Claims(annual growth as % of broad money) in Mauritius?
Keep it short and to the point. 9.22. In the year 2009, what is the difference between the Claims(annual growth as % of broad money) of Kenya and Claims(annual growth as % of broad money) of Paraguay?
Give a very brief answer. -4.58. In the year 2009, what is the difference between the Claims(annual growth as % of broad money) in Mauritius and Claims(annual growth as % of broad money) in Paraguay?
Your response must be concise. -13.8. In the year 2010, what is the difference between the Claims(annual growth as % of broad money) of Croatia and Claims(annual growth as % of broad money) of Kenya?
Offer a terse response. -12.38. In the year 2010, what is the difference between the Claims(annual growth as % of broad money) in Croatia and Claims(annual growth as % of broad money) in Mauritius?
Give a very brief answer. -8.76. In the year 2010, what is the difference between the Claims(annual growth as % of broad money) in Croatia and Claims(annual growth as % of broad money) in Paraguay?
Make the answer very short. -25.63. In the year 2010, what is the difference between the Claims(annual growth as % of broad money) of Kenya and Claims(annual growth as % of broad money) of Mauritius?
Provide a succinct answer. 3.62. In the year 2010, what is the difference between the Claims(annual growth as % of broad money) in Kenya and Claims(annual growth as % of broad money) in Paraguay?
Provide a short and direct response. -13.25. In the year 2010, what is the difference between the Claims(annual growth as % of broad money) of Mauritius and Claims(annual growth as % of broad money) of Paraguay?
Keep it short and to the point. -16.87. In the year 2011, what is the difference between the Claims(annual growth as % of broad money) in Croatia and Claims(annual growth as % of broad money) in Kenya?
Your response must be concise. -17.99. In the year 2011, what is the difference between the Claims(annual growth as % of broad money) in Croatia and Claims(annual growth as % of broad money) in Mauritius?
Keep it short and to the point. -7.17. In the year 2011, what is the difference between the Claims(annual growth as % of broad money) in Croatia and Claims(annual growth as % of broad money) in Paraguay?
Keep it short and to the point. -17.44. In the year 2011, what is the difference between the Claims(annual growth as % of broad money) of Kenya and Claims(annual growth as % of broad money) of Mauritius?
Your answer should be very brief. 10.82. In the year 2011, what is the difference between the Claims(annual growth as % of broad money) in Kenya and Claims(annual growth as % of broad money) in Paraguay?
Provide a succinct answer. 0.55. In the year 2011, what is the difference between the Claims(annual growth as % of broad money) of Mauritius and Claims(annual growth as % of broad money) of Paraguay?
Provide a short and direct response. -10.26. In the year 2012, what is the difference between the Claims(annual growth as % of broad money) of Kenya and Claims(annual growth as % of broad money) of Mauritius?
Provide a short and direct response. -8.21. In the year 2012, what is the difference between the Claims(annual growth as % of broad money) of Kenya and Claims(annual growth as % of broad money) of Paraguay?
Ensure brevity in your answer.  -4.36. In the year 2012, what is the difference between the Claims(annual growth as % of broad money) in Mauritius and Claims(annual growth as % of broad money) in Paraguay?
Your answer should be very brief. 3.85. What is the ratio of the Claims(annual growth as % of broad money) of Croatia in 2006 to that in 2007?
Give a very brief answer. 1.46. What is the ratio of the Claims(annual growth as % of broad money) of Kenya in 2006 to that in 2007?
Your response must be concise. 0.91. What is the ratio of the Claims(annual growth as % of broad money) of Mauritius in 2006 to that in 2007?
Offer a terse response. 0.49. What is the ratio of the Claims(annual growth as % of broad money) of Paraguay in 2006 to that in 2007?
Offer a terse response. 0.22. What is the ratio of the Claims(annual growth as % of broad money) in Croatia in 2006 to that in 2008?
Provide a succinct answer. 1.87. What is the ratio of the Claims(annual growth as % of broad money) of Kenya in 2006 to that in 2008?
Offer a terse response. 0.57. What is the ratio of the Claims(annual growth as % of broad money) of Mauritius in 2006 to that in 2008?
Offer a very short reply. 0.35. What is the ratio of the Claims(annual growth as % of broad money) in Paraguay in 2006 to that in 2008?
Your answer should be very brief. 0.13. What is the ratio of the Claims(annual growth as % of broad money) in Kenya in 2006 to that in 2009?
Give a very brief answer. 1.02. What is the ratio of the Claims(annual growth as % of broad money) in Mauritius in 2006 to that in 2009?
Your answer should be very brief. 17.61. What is the ratio of the Claims(annual growth as % of broad money) in Paraguay in 2006 to that in 2009?
Your answer should be very brief. 0.35. What is the ratio of the Claims(annual growth as % of broad money) in Croatia in 2006 to that in 2010?
Offer a terse response. 12.53. What is the ratio of the Claims(annual growth as % of broad money) of Kenya in 2006 to that in 2010?
Offer a terse response. 0.7. What is the ratio of the Claims(annual growth as % of broad money) of Mauritius in 2006 to that in 2010?
Your answer should be very brief. 0.69. What is the ratio of the Claims(annual growth as % of broad money) in Paraguay in 2006 to that in 2010?
Ensure brevity in your answer.  0.18. What is the ratio of the Claims(annual growth as % of broad money) in Croatia in 2006 to that in 2011?
Provide a short and direct response. 5.67. What is the ratio of the Claims(annual growth as % of broad money) of Kenya in 2006 to that in 2011?
Provide a short and direct response. 0.46. What is the ratio of the Claims(annual growth as % of broad money) in Mauritius in 2006 to that in 2011?
Provide a short and direct response. 0.66. What is the ratio of the Claims(annual growth as % of broad money) in Paraguay in 2006 to that in 2011?
Keep it short and to the point. 0.23. What is the ratio of the Claims(annual growth as % of broad money) in Kenya in 2006 to that in 2012?
Give a very brief answer. 1.25. What is the ratio of the Claims(annual growth as % of broad money) in Mauritius in 2006 to that in 2012?
Provide a succinct answer. 0.45. What is the ratio of the Claims(annual growth as % of broad money) in Paraguay in 2006 to that in 2012?
Ensure brevity in your answer.  0.4. What is the ratio of the Claims(annual growth as % of broad money) in Croatia in 2007 to that in 2008?
Give a very brief answer. 1.28. What is the ratio of the Claims(annual growth as % of broad money) of Kenya in 2007 to that in 2008?
Give a very brief answer. 0.62. What is the ratio of the Claims(annual growth as % of broad money) in Mauritius in 2007 to that in 2008?
Your answer should be very brief. 0.7. What is the ratio of the Claims(annual growth as % of broad money) in Paraguay in 2007 to that in 2008?
Your response must be concise. 0.58. What is the ratio of the Claims(annual growth as % of broad money) of Kenya in 2007 to that in 2009?
Offer a terse response. 1.12. What is the ratio of the Claims(annual growth as % of broad money) of Mauritius in 2007 to that in 2009?
Your answer should be compact. 35.58. What is the ratio of the Claims(annual growth as % of broad money) in Paraguay in 2007 to that in 2009?
Provide a succinct answer. 1.6. What is the ratio of the Claims(annual growth as % of broad money) in Croatia in 2007 to that in 2010?
Your answer should be compact. 8.61. What is the ratio of the Claims(annual growth as % of broad money) of Kenya in 2007 to that in 2010?
Provide a short and direct response. 0.77. What is the ratio of the Claims(annual growth as % of broad money) of Mauritius in 2007 to that in 2010?
Offer a very short reply. 1.39. What is the ratio of the Claims(annual growth as % of broad money) in Paraguay in 2007 to that in 2010?
Your answer should be very brief. 0.84. What is the ratio of the Claims(annual growth as % of broad money) in Croatia in 2007 to that in 2011?
Your answer should be compact. 3.9. What is the ratio of the Claims(annual growth as % of broad money) of Kenya in 2007 to that in 2011?
Provide a short and direct response. 0.5. What is the ratio of the Claims(annual growth as % of broad money) in Mauritius in 2007 to that in 2011?
Offer a very short reply. 1.34. What is the ratio of the Claims(annual growth as % of broad money) in Paraguay in 2007 to that in 2011?
Make the answer very short. 1.08. What is the ratio of the Claims(annual growth as % of broad money) of Kenya in 2007 to that in 2012?
Provide a short and direct response. 1.38. What is the ratio of the Claims(annual growth as % of broad money) of Mauritius in 2007 to that in 2012?
Make the answer very short. 0.9. What is the ratio of the Claims(annual growth as % of broad money) in Paraguay in 2007 to that in 2012?
Offer a terse response. 1.87. What is the ratio of the Claims(annual growth as % of broad money) in Kenya in 2008 to that in 2009?
Ensure brevity in your answer.  1.8. What is the ratio of the Claims(annual growth as % of broad money) in Mauritius in 2008 to that in 2009?
Make the answer very short. 50.78. What is the ratio of the Claims(annual growth as % of broad money) of Paraguay in 2008 to that in 2009?
Your response must be concise. 2.76. What is the ratio of the Claims(annual growth as % of broad money) in Croatia in 2008 to that in 2010?
Offer a very short reply. 6.7. What is the ratio of the Claims(annual growth as % of broad money) of Kenya in 2008 to that in 2010?
Your answer should be very brief. 1.24. What is the ratio of the Claims(annual growth as % of broad money) of Mauritius in 2008 to that in 2010?
Make the answer very short. 1.98. What is the ratio of the Claims(annual growth as % of broad money) in Paraguay in 2008 to that in 2010?
Provide a short and direct response. 1.44. What is the ratio of the Claims(annual growth as % of broad money) of Croatia in 2008 to that in 2011?
Provide a short and direct response. 3.03. What is the ratio of the Claims(annual growth as % of broad money) of Kenya in 2008 to that in 2011?
Make the answer very short. 0.8. What is the ratio of the Claims(annual growth as % of broad money) in Mauritius in 2008 to that in 2011?
Keep it short and to the point. 1.91. What is the ratio of the Claims(annual growth as % of broad money) in Paraguay in 2008 to that in 2011?
Your response must be concise. 1.86. What is the ratio of the Claims(annual growth as % of broad money) of Kenya in 2008 to that in 2012?
Your answer should be compact. 2.21. What is the ratio of the Claims(annual growth as % of broad money) of Mauritius in 2008 to that in 2012?
Offer a terse response. 1.29. What is the ratio of the Claims(annual growth as % of broad money) in Paraguay in 2008 to that in 2012?
Your answer should be very brief. 3.21. What is the ratio of the Claims(annual growth as % of broad money) of Kenya in 2009 to that in 2010?
Ensure brevity in your answer.  0.69. What is the ratio of the Claims(annual growth as % of broad money) in Mauritius in 2009 to that in 2010?
Provide a succinct answer. 0.04. What is the ratio of the Claims(annual growth as % of broad money) of Paraguay in 2009 to that in 2010?
Ensure brevity in your answer.  0.52. What is the ratio of the Claims(annual growth as % of broad money) in Kenya in 2009 to that in 2011?
Provide a short and direct response. 0.45. What is the ratio of the Claims(annual growth as % of broad money) in Mauritius in 2009 to that in 2011?
Ensure brevity in your answer.  0.04. What is the ratio of the Claims(annual growth as % of broad money) of Paraguay in 2009 to that in 2011?
Provide a short and direct response. 0.67. What is the ratio of the Claims(annual growth as % of broad money) in Kenya in 2009 to that in 2012?
Ensure brevity in your answer.  1.23. What is the ratio of the Claims(annual growth as % of broad money) of Mauritius in 2009 to that in 2012?
Your response must be concise. 0.03. What is the ratio of the Claims(annual growth as % of broad money) in Paraguay in 2009 to that in 2012?
Your answer should be compact. 1.16. What is the ratio of the Claims(annual growth as % of broad money) of Croatia in 2010 to that in 2011?
Provide a short and direct response. 0.45. What is the ratio of the Claims(annual growth as % of broad money) in Kenya in 2010 to that in 2011?
Ensure brevity in your answer.  0.65. What is the ratio of the Claims(annual growth as % of broad money) in Mauritius in 2010 to that in 2011?
Your answer should be compact. 0.96. What is the ratio of the Claims(annual growth as % of broad money) in Paraguay in 2010 to that in 2011?
Provide a succinct answer. 1.29. What is the ratio of the Claims(annual growth as % of broad money) of Kenya in 2010 to that in 2012?
Provide a short and direct response. 1.79. What is the ratio of the Claims(annual growth as % of broad money) in Mauritius in 2010 to that in 2012?
Your response must be concise. 0.65. What is the ratio of the Claims(annual growth as % of broad money) of Paraguay in 2010 to that in 2012?
Provide a succinct answer. 2.23. What is the ratio of the Claims(annual growth as % of broad money) in Kenya in 2011 to that in 2012?
Your response must be concise. 2.75. What is the ratio of the Claims(annual growth as % of broad money) of Mauritius in 2011 to that in 2012?
Your answer should be very brief. 0.67. What is the ratio of the Claims(annual growth as % of broad money) in Paraguay in 2011 to that in 2012?
Ensure brevity in your answer.  1.72. What is the difference between the highest and the second highest Claims(annual growth as % of broad money) of Croatia?
Your answer should be compact. 6.44. What is the difference between the highest and the second highest Claims(annual growth as % of broad money) in Kenya?
Keep it short and to the point. 4.29. What is the difference between the highest and the second highest Claims(annual growth as % of broad money) of Mauritius?
Offer a very short reply. 4.59. What is the difference between the highest and the second highest Claims(annual growth as % of broad money) of Paraguay?
Offer a terse response. 11.93. What is the difference between the highest and the lowest Claims(annual growth as % of broad money) in Croatia?
Offer a terse response. 20.58. What is the difference between the highest and the lowest Claims(annual growth as % of broad money) of Kenya?
Your answer should be very brief. 13.76. What is the difference between the highest and the lowest Claims(annual growth as % of broad money) in Mauritius?
Provide a succinct answer. 20.24. What is the difference between the highest and the lowest Claims(annual growth as % of broad money) of Paraguay?
Your answer should be very brief. 34.28. 